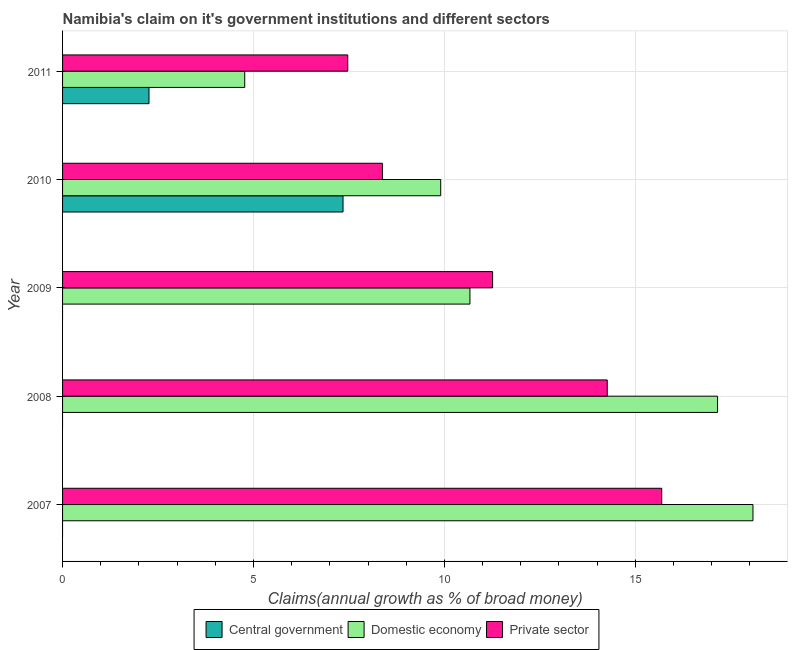How many different coloured bars are there?
Provide a succinct answer. 3. Are the number of bars per tick equal to the number of legend labels?
Your answer should be very brief. No. How many bars are there on the 2nd tick from the top?
Your response must be concise. 3. What is the label of the 3rd group of bars from the top?
Offer a very short reply. 2009. What is the percentage of claim on the central government in 2011?
Make the answer very short. 2.26. Across all years, what is the maximum percentage of claim on the central government?
Give a very brief answer. 7.35. In which year was the percentage of claim on the domestic economy maximum?
Ensure brevity in your answer.  2007. What is the total percentage of claim on the central government in the graph?
Give a very brief answer. 9.61. What is the difference between the percentage of claim on the private sector in 2008 and that in 2009?
Offer a terse response. 3. What is the difference between the percentage of claim on the domestic economy in 2008 and the percentage of claim on the private sector in 2009?
Offer a terse response. 5.89. What is the average percentage of claim on the domestic economy per year?
Provide a succinct answer. 12.12. In the year 2010, what is the difference between the percentage of claim on the central government and percentage of claim on the domestic economy?
Keep it short and to the point. -2.56. In how many years, is the percentage of claim on the central government greater than 6 %?
Provide a succinct answer. 1. What is the ratio of the percentage of claim on the domestic economy in 2010 to that in 2011?
Ensure brevity in your answer.  2.08. Is the percentage of claim on the domestic economy in 2008 less than that in 2011?
Provide a short and direct response. No. What is the difference between the highest and the second highest percentage of claim on the private sector?
Your answer should be compact. 1.43. What is the difference between the highest and the lowest percentage of claim on the domestic economy?
Give a very brief answer. 13.31. In how many years, is the percentage of claim on the central government greater than the average percentage of claim on the central government taken over all years?
Make the answer very short. 2. Is it the case that in every year, the sum of the percentage of claim on the central government and percentage of claim on the domestic economy is greater than the percentage of claim on the private sector?
Your response must be concise. No. Are all the bars in the graph horizontal?
Offer a terse response. Yes. How many years are there in the graph?
Offer a very short reply. 5. Are the values on the major ticks of X-axis written in scientific E-notation?
Keep it short and to the point. No. Does the graph contain grids?
Offer a terse response. Yes. How are the legend labels stacked?
Your answer should be very brief. Horizontal. What is the title of the graph?
Ensure brevity in your answer.  Namibia's claim on it's government institutions and different sectors. What is the label or title of the X-axis?
Keep it short and to the point. Claims(annual growth as % of broad money). What is the label or title of the Y-axis?
Provide a succinct answer. Year. What is the Claims(annual growth as % of broad money) of Central government in 2007?
Your response must be concise. 0. What is the Claims(annual growth as % of broad money) of Domestic economy in 2007?
Offer a very short reply. 18.08. What is the Claims(annual growth as % of broad money) of Private sector in 2007?
Offer a terse response. 15.69. What is the Claims(annual growth as % of broad money) in Domestic economy in 2008?
Offer a very short reply. 17.15. What is the Claims(annual growth as % of broad money) in Private sector in 2008?
Make the answer very short. 14.27. What is the Claims(annual growth as % of broad money) of Central government in 2009?
Provide a short and direct response. 0. What is the Claims(annual growth as % of broad money) in Domestic economy in 2009?
Keep it short and to the point. 10.67. What is the Claims(annual growth as % of broad money) of Private sector in 2009?
Your answer should be compact. 11.26. What is the Claims(annual growth as % of broad money) in Central government in 2010?
Offer a very short reply. 7.35. What is the Claims(annual growth as % of broad money) in Domestic economy in 2010?
Keep it short and to the point. 9.9. What is the Claims(annual growth as % of broad money) in Private sector in 2010?
Your answer should be very brief. 8.38. What is the Claims(annual growth as % of broad money) in Central government in 2011?
Keep it short and to the point. 2.26. What is the Claims(annual growth as % of broad money) of Domestic economy in 2011?
Give a very brief answer. 4.77. What is the Claims(annual growth as % of broad money) of Private sector in 2011?
Provide a short and direct response. 7.47. Across all years, what is the maximum Claims(annual growth as % of broad money) in Central government?
Make the answer very short. 7.35. Across all years, what is the maximum Claims(annual growth as % of broad money) of Domestic economy?
Your answer should be compact. 18.08. Across all years, what is the maximum Claims(annual growth as % of broad money) of Private sector?
Keep it short and to the point. 15.69. Across all years, what is the minimum Claims(annual growth as % of broad money) of Central government?
Your answer should be compact. 0. Across all years, what is the minimum Claims(annual growth as % of broad money) of Domestic economy?
Ensure brevity in your answer.  4.77. Across all years, what is the minimum Claims(annual growth as % of broad money) of Private sector?
Your response must be concise. 7.47. What is the total Claims(annual growth as % of broad money) in Central government in the graph?
Ensure brevity in your answer.  9.61. What is the total Claims(annual growth as % of broad money) in Domestic economy in the graph?
Your answer should be compact. 60.58. What is the total Claims(annual growth as % of broad money) in Private sector in the graph?
Your answer should be very brief. 57.07. What is the difference between the Claims(annual growth as % of broad money) in Domestic economy in 2007 and that in 2008?
Offer a very short reply. 0.93. What is the difference between the Claims(annual growth as % of broad money) of Private sector in 2007 and that in 2008?
Offer a terse response. 1.43. What is the difference between the Claims(annual growth as % of broad money) of Domestic economy in 2007 and that in 2009?
Keep it short and to the point. 7.41. What is the difference between the Claims(annual growth as % of broad money) of Private sector in 2007 and that in 2009?
Make the answer very short. 4.43. What is the difference between the Claims(annual growth as % of broad money) in Domestic economy in 2007 and that in 2010?
Offer a very short reply. 8.18. What is the difference between the Claims(annual growth as % of broad money) in Private sector in 2007 and that in 2010?
Offer a terse response. 7.32. What is the difference between the Claims(annual growth as % of broad money) in Domestic economy in 2007 and that in 2011?
Give a very brief answer. 13.31. What is the difference between the Claims(annual growth as % of broad money) in Private sector in 2007 and that in 2011?
Your answer should be compact. 8.22. What is the difference between the Claims(annual growth as % of broad money) of Domestic economy in 2008 and that in 2009?
Keep it short and to the point. 6.49. What is the difference between the Claims(annual growth as % of broad money) in Private sector in 2008 and that in 2009?
Your answer should be very brief. 3. What is the difference between the Claims(annual growth as % of broad money) in Domestic economy in 2008 and that in 2010?
Your response must be concise. 7.25. What is the difference between the Claims(annual growth as % of broad money) of Private sector in 2008 and that in 2010?
Make the answer very short. 5.89. What is the difference between the Claims(annual growth as % of broad money) in Domestic economy in 2008 and that in 2011?
Provide a short and direct response. 12.38. What is the difference between the Claims(annual growth as % of broad money) in Private sector in 2008 and that in 2011?
Your answer should be very brief. 6.8. What is the difference between the Claims(annual growth as % of broad money) in Domestic economy in 2009 and that in 2010?
Keep it short and to the point. 0.77. What is the difference between the Claims(annual growth as % of broad money) in Private sector in 2009 and that in 2010?
Ensure brevity in your answer.  2.89. What is the difference between the Claims(annual growth as % of broad money) of Domestic economy in 2009 and that in 2011?
Provide a short and direct response. 5.9. What is the difference between the Claims(annual growth as % of broad money) in Private sector in 2009 and that in 2011?
Keep it short and to the point. 3.79. What is the difference between the Claims(annual growth as % of broad money) in Central government in 2010 and that in 2011?
Your answer should be compact. 5.08. What is the difference between the Claims(annual growth as % of broad money) of Domestic economy in 2010 and that in 2011?
Ensure brevity in your answer.  5.13. What is the difference between the Claims(annual growth as % of broad money) of Private sector in 2010 and that in 2011?
Offer a very short reply. 0.91. What is the difference between the Claims(annual growth as % of broad money) in Domestic economy in 2007 and the Claims(annual growth as % of broad money) in Private sector in 2008?
Make the answer very short. 3.82. What is the difference between the Claims(annual growth as % of broad money) in Domestic economy in 2007 and the Claims(annual growth as % of broad money) in Private sector in 2009?
Provide a succinct answer. 6.82. What is the difference between the Claims(annual growth as % of broad money) of Domestic economy in 2007 and the Claims(annual growth as % of broad money) of Private sector in 2010?
Your answer should be very brief. 9.7. What is the difference between the Claims(annual growth as % of broad money) of Domestic economy in 2007 and the Claims(annual growth as % of broad money) of Private sector in 2011?
Provide a short and direct response. 10.61. What is the difference between the Claims(annual growth as % of broad money) of Domestic economy in 2008 and the Claims(annual growth as % of broad money) of Private sector in 2009?
Ensure brevity in your answer.  5.89. What is the difference between the Claims(annual growth as % of broad money) of Domestic economy in 2008 and the Claims(annual growth as % of broad money) of Private sector in 2010?
Provide a succinct answer. 8.78. What is the difference between the Claims(annual growth as % of broad money) in Domestic economy in 2008 and the Claims(annual growth as % of broad money) in Private sector in 2011?
Give a very brief answer. 9.69. What is the difference between the Claims(annual growth as % of broad money) of Domestic economy in 2009 and the Claims(annual growth as % of broad money) of Private sector in 2010?
Offer a terse response. 2.29. What is the difference between the Claims(annual growth as % of broad money) in Domestic economy in 2009 and the Claims(annual growth as % of broad money) in Private sector in 2011?
Give a very brief answer. 3.2. What is the difference between the Claims(annual growth as % of broad money) of Central government in 2010 and the Claims(annual growth as % of broad money) of Domestic economy in 2011?
Provide a short and direct response. 2.57. What is the difference between the Claims(annual growth as % of broad money) in Central government in 2010 and the Claims(annual growth as % of broad money) in Private sector in 2011?
Offer a very short reply. -0.12. What is the difference between the Claims(annual growth as % of broad money) of Domestic economy in 2010 and the Claims(annual growth as % of broad money) of Private sector in 2011?
Ensure brevity in your answer.  2.43. What is the average Claims(annual growth as % of broad money) of Central government per year?
Give a very brief answer. 1.92. What is the average Claims(annual growth as % of broad money) of Domestic economy per year?
Offer a very short reply. 12.12. What is the average Claims(annual growth as % of broad money) in Private sector per year?
Your answer should be compact. 11.41. In the year 2007, what is the difference between the Claims(annual growth as % of broad money) in Domestic economy and Claims(annual growth as % of broad money) in Private sector?
Provide a short and direct response. 2.39. In the year 2008, what is the difference between the Claims(annual growth as % of broad money) in Domestic economy and Claims(annual growth as % of broad money) in Private sector?
Ensure brevity in your answer.  2.89. In the year 2009, what is the difference between the Claims(annual growth as % of broad money) in Domestic economy and Claims(annual growth as % of broad money) in Private sector?
Your answer should be compact. -0.59. In the year 2010, what is the difference between the Claims(annual growth as % of broad money) of Central government and Claims(annual growth as % of broad money) of Domestic economy?
Your response must be concise. -2.56. In the year 2010, what is the difference between the Claims(annual growth as % of broad money) of Central government and Claims(annual growth as % of broad money) of Private sector?
Your answer should be very brief. -1.03. In the year 2010, what is the difference between the Claims(annual growth as % of broad money) in Domestic economy and Claims(annual growth as % of broad money) in Private sector?
Make the answer very short. 1.53. In the year 2011, what is the difference between the Claims(annual growth as % of broad money) in Central government and Claims(annual growth as % of broad money) in Domestic economy?
Keep it short and to the point. -2.51. In the year 2011, what is the difference between the Claims(annual growth as % of broad money) of Central government and Claims(annual growth as % of broad money) of Private sector?
Give a very brief answer. -5.21. In the year 2011, what is the difference between the Claims(annual growth as % of broad money) in Domestic economy and Claims(annual growth as % of broad money) in Private sector?
Offer a terse response. -2.7. What is the ratio of the Claims(annual growth as % of broad money) in Domestic economy in 2007 to that in 2008?
Your response must be concise. 1.05. What is the ratio of the Claims(annual growth as % of broad money) of Private sector in 2007 to that in 2008?
Make the answer very short. 1.1. What is the ratio of the Claims(annual growth as % of broad money) of Domestic economy in 2007 to that in 2009?
Provide a succinct answer. 1.69. What is the ratio of the Claims(annual growth as % of broad money) of Private sector in 2007 to that in 2009?
Provide a succinct answer. 1.39. What is the ratio of the Claims(annual growth as % of broad money) of Domestic economy in 2007 to that in 2010?
Keep it short and to the point. 1.83. What is the ratio of the Claims(annual growth as % of broad money) in Private sector in 2007 to that in 2010?
Your answer should be very brief. 1.87. What is the ratio of the Claims(annual growth as % of broad money) in Domestic economy in 2007 to that in 2011?
Keep it short and to the point. 3.79. What is the ratio of the Claims(annual growth as % of broad money) of Private sector in 2007 to that in 2011?
Ensure brevity in your answer.  2.1. What is the ratio of the Claims(annual growth as % of broad money) in Domestic economy in 2008 to that in 2009?
Provide a succinct answer. 1.61. What is the ratio of the Claims(annual growth as % of broad money) of Private sector in 2008 to that in 2009?
Offer a terse response. 1.27. What is the ratio of the Claims(annual growth as % of broad money) of Domestic economy in 2008 to that in 2010?
Give a very brief answer. 1.73. What is the ratio of the Claims(annual growth as % of broad money) in Private sector in 2008 to that in 2010?
Provide a short and direct response. 1.7. What is the ratio of the Claims(annual growth as % of broad money) in Domestic economy in 2008 to that in 2011?
Offer a terse response. 3.6. What is the ratio of the Claims(annual growth as % of broad money) of Private sector in 2008 to that in 2011?
Give a very brief answer. 1.91. What is the ratio of the Claims(annual growth as % of broad money) of Domestic economy in 2009 to that in 2010?
Ensure brevity in your answer.  1.08. What is the ratio of the Claims(annual growth as % of broad money) in Private sector in 2009 to that in 2010?
Provide a short and direct response. 1.34. What is the ratio of the Claims(annual growth as % of broad money) in Domestic economy in 2009 to that in 2011?
Your answer should be very brief. 2.24. What is the ratio of the Claims(annual growth as % of broad money) of Private sector in 2009 to that in 2011?
Ensure brevity in your answer.  1.51. What is the ratio of the Claims(annual growth as % of broad money) in Central government in 2010 to that in 2011?
Your response must be concise. 3.24. What is the ratio of the Claims(annual growth as % of broad money) in Domestic economy in 2010 to that in 2011?
Offer a very short reply. 2.08. What is the ratio of the Claims(annual growth as % of broad money) in Private sector in 2010 to that in 2011?
Ensure brevity in your answer.  1.12. What is the difference between the highest and the second highest Claims(annual growth as % of broad money) of Domestic economy?
Offer a terse response. 0.93. What is the difference between the highest and the second highest Claims(annual growth as % of broad money) of Private sector?
Provide a short and direct response. 1.43. What is the difference between the highest and the lowest Claims(annual growth as % of broad money) of Central government?
Offer a very short reply. 7.35. What is the difference between the highest and the lowest Claims(annual growth as % of broad money) of Domestic economy?
Provide a short and direct response. 13.31. What is the difference between the highest and the lowest Claims(annual growth as % of broad money) in Private sector?
Offer a terse response. 8.22. 